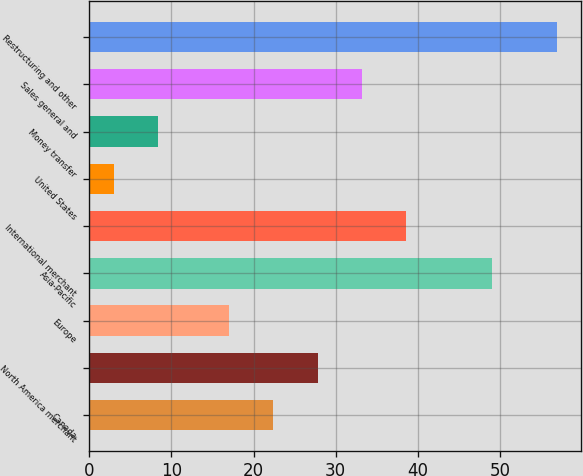<chart> <loc_0><loc_0><loc_500><loc_500><bar_chart><fcel>Canada<fcel>North America merchant<fcel>Europe<fcel>Asia-Pacific<fcel>International merchant<fcel>United States<fcel>Money transfer<fcel>Sales general and<fcel>Restructuring and other<nl><fcel>22.4<fcel>27.8<fcel>17<fcel>49<fcel>38.6<fcel>3<fcel>8.4<fcel>33.2<fcel>57<nl></chart> 